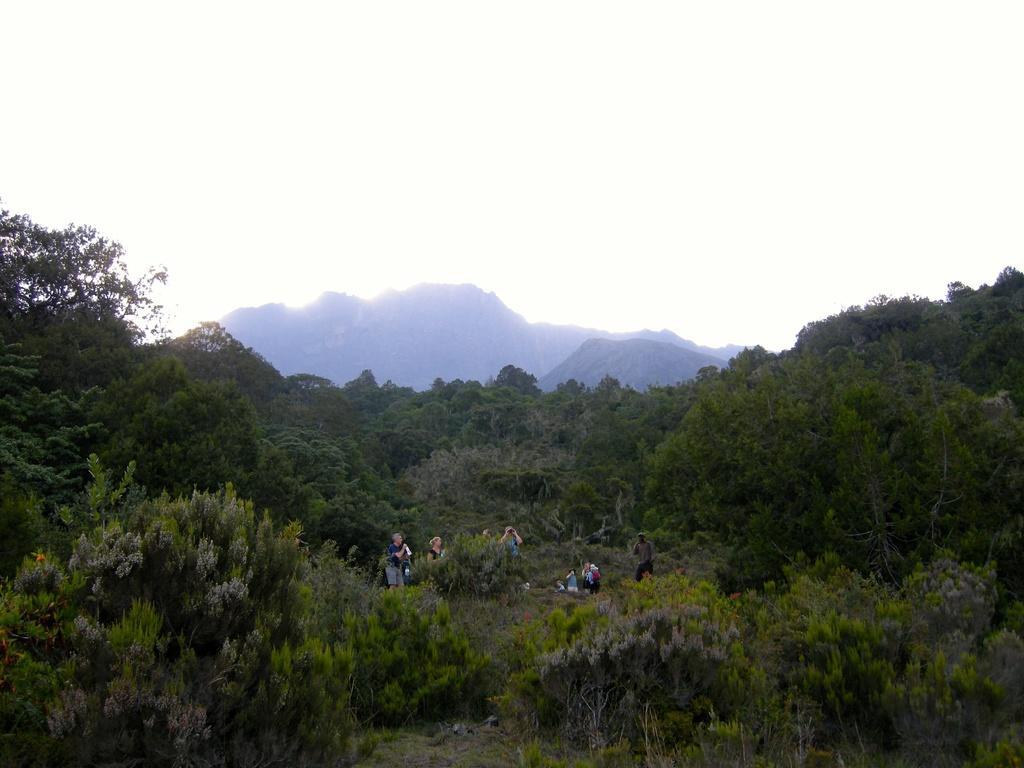Describe this image in one or two sentences. A picture of a forest, as we can there are number of trees and mountains. Few persons are standing and few persons are sitting. 